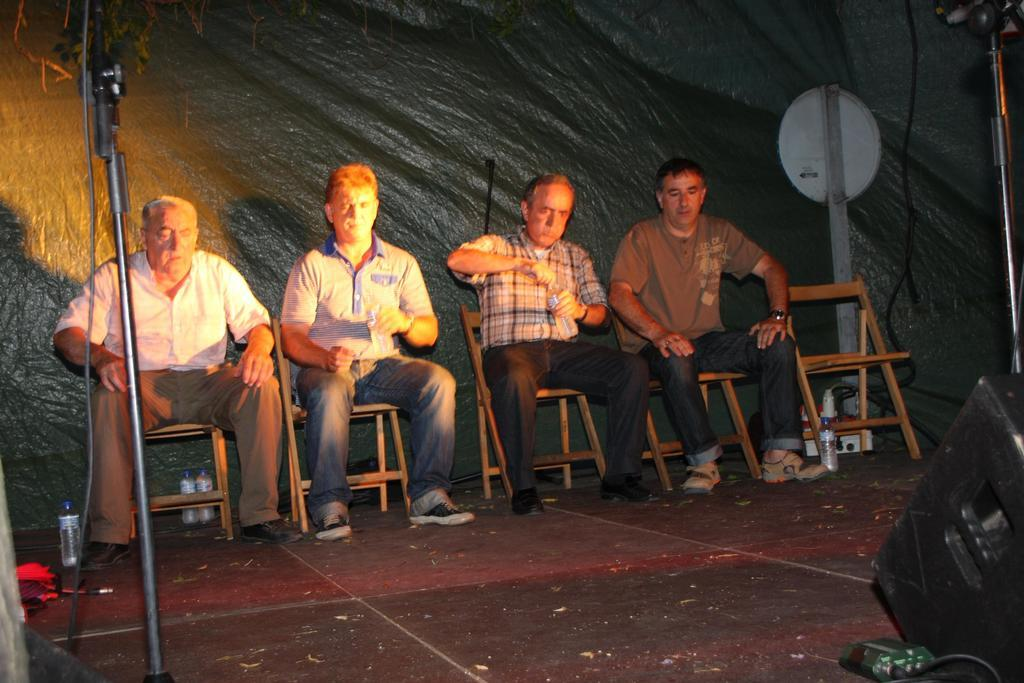How many persons are sitting on cars in the image? There are four persons sitting on cars in the image. What else can be seen in the image besides the persons on cars? Bottles, microphone stands, and a speaker are visible in the image. Can you describe the presence of the speaker in the image? There is a speaker in the image, which is typically used for amplifying sound. What are the unspecified objects in the image? Unfortunately, the facts provided do not specify the nature of the unspecified objects in the image. How old is the baby in the image? There is no baby present in the image. What is the account balance of the person holding the microphone in the image? There is no information about an account balance in the image. 